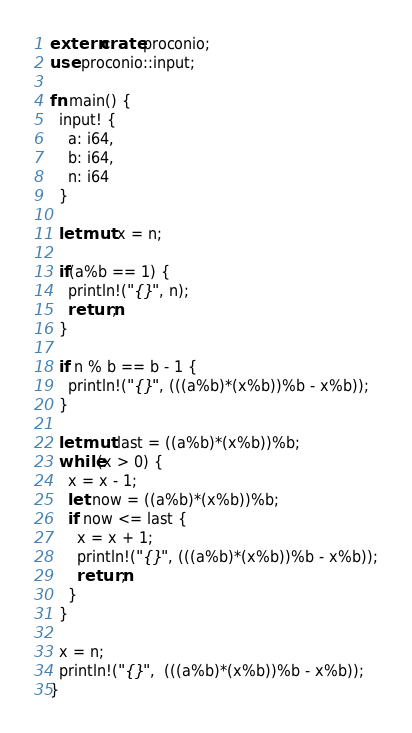<code> <loc_0><loc_0><loc_500><loc_500><_Rust_>extern crate proconio;
use proconio::input;
 
fn main() {
  input! {
    a: i64,
    b: i64,
    n: i64
  }
  
  let mut x = n;
  
  if(a%b == 1) {
    println!("{}", n);
    return;
  }
  
  if n % b == b - 1 {
    println!("{}", (((a%b)*(x%b))%b - x%b));
  }
  
  let mut last = ((a%b)*(x%b))%b;
  while(x > 0) {
    x = x - 1;
    let now = ((a%b)*(x%b))%b;
    if now <= last {
      x = x + 1;
      println!("{}", (((a%b)*(x%b))%b - x%b));
      return;
    }
  }
  
  x = n;
  println!("{}",  (((a%b)*(x%b))%b - x%b));
}
</code> 